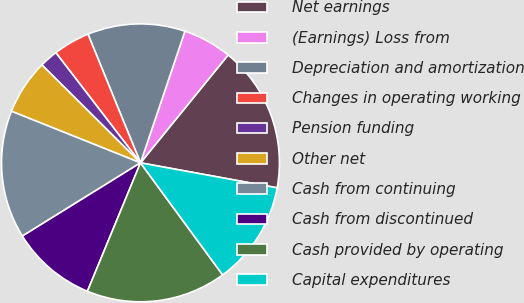Convert chart. <chart><loc_0><loc_0><loc_500><loc_500><pie_chart><fcel>Net earnings<fcel>(Earnings) Loss from<fcel>Depreciation and amortization<fcel>Changes in operating working<fcel>Pension funding<fcel>Other net<fcel>Cash from continuing<fcel>Cash from discontinued<fcel>Cash provided by operating<fcel>Capital expenditures<nl><fcel>17.02%<fcel>5.68%<fcel>11.35%<fcel>4.26%<fcel>2.13%<fcel>6.39%<fcel>14.89%<fcel>9.93%<fcel>16.31%<fcel>12.05%<nl></chart> 